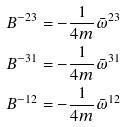<formula> <loc_0><loc_0><loc_500><loc_500>B ^ { - 2 3 } & = - \frac { 1 } { 4 m } \bar { \omega } ^ { 2 3 } \\ B ^ { - 3 1 } & = - \frac { 1 } { 4 m } \bar { \omega } ^ { 3 1 } \\ B ^ { - 1 2 } & = - \frac { 1 } { 4 m } \bar { \omega } ^ { 1 2 }</formula> 